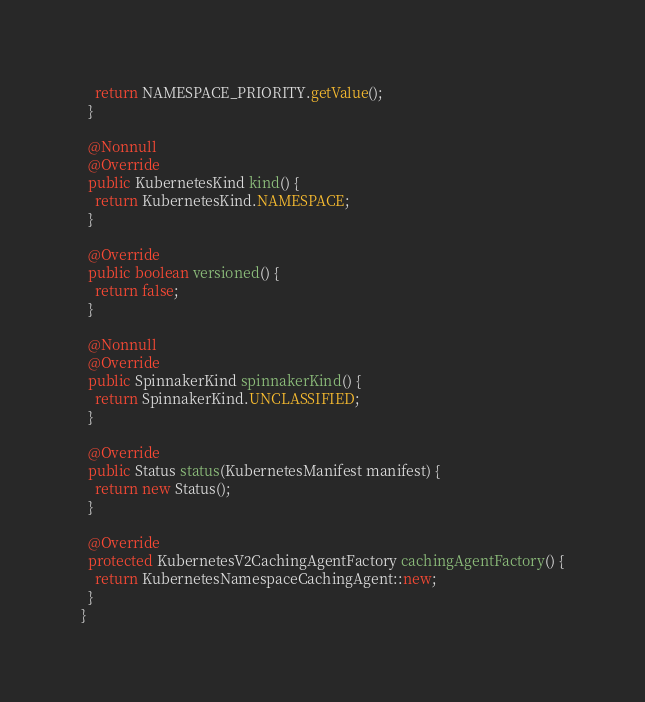Convert code to text. <code><loc_0><loc_0><loc_500><loc_500><_Java_>    return NAMESPACE_PRIORITY.getValue();
  }

  @Nonnull
  @Override
  public KubernetesKind kind() {
    return KubernetesKind.NAMESPACE;
  }

  @Override
  public boolean versioned() {
    return false;
  }

  @Nonnull
  @Override
  public SpinnakerKind spinnakerKind() {
    return SpinnakerKind.UNCLASSIFIED;
  }

  @Override
  public Status status(KubernetesManifest manifest) {
    return new Status();
  }

  @Override
  protected KubernetesV2CachingAgentFactory cachingAgentFactory() {
    return KubernetesNamespaceCachingAgent::new;
  }
}
</code> 